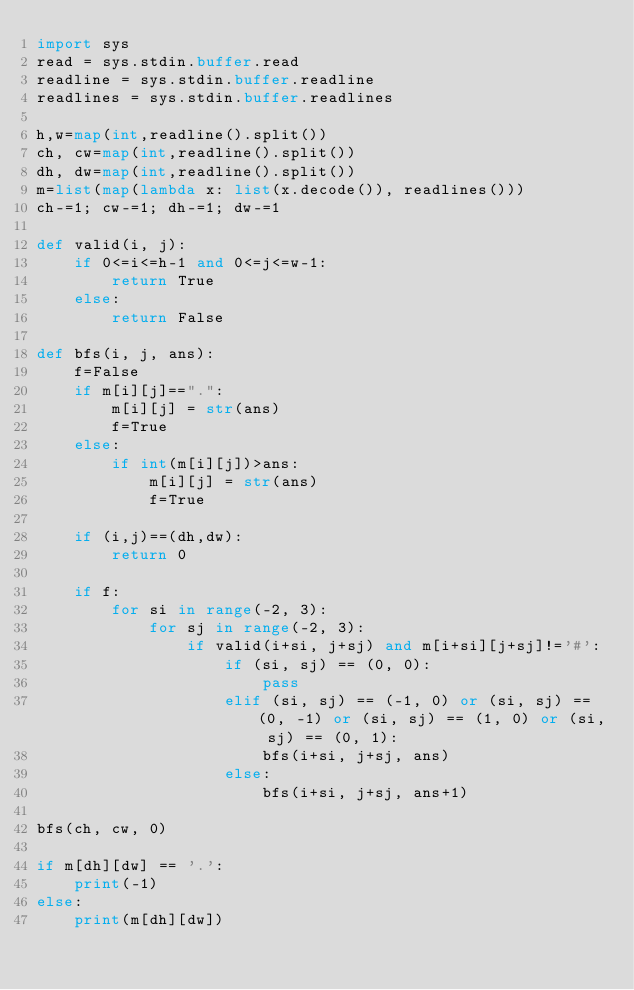Convert code to text. <code><loc_0><loc_0><loc_500><loc_500><_Python_>import sys
read = sys.stdin.buffer.read
readline = sys.stdin.buffer.readline
readlines = sys.stdin.buffer.readlines

h,w=map(int,readline().split())
ch, cw=map(int,readline().split())
dh, dw=map(int,readline().split())
m=list(map(lambda x: list(x.decode()), readlines()))
ch-=1; cw-=1; dh-=1; dw-=1

def valid(i, j):
    if 0<=i<=h-1 and 0<=j<=w-1:
        return True
    else:
        return False

def bfs(i, j, ans):
    f=False
    if m[i][j]==".":
        m[i][j] = str(ans)
        f=True
    else:
        if int(m[i][j])>ans:
            m[i][j] = str(ans)
            f=True
            
    if (i,j)==(dh,dw):
        return 0
    
    if f:
        for si in range(-2, 3):
            for sj in range(-2, 3):
                if valid(i+si, j+sj) and m[i+si][j+sj]!='#':
                    if (si, sj) == (0, 0):
                        pass
                    elif (si, sj) == (-1, 0) or (si, sj) == (0, -1) or (si, sj) == (1, 0) or (si, sj) == (0, 1):
                        bfs(i+si, j+sj, ans)
                    else:
                        bfs(i+si, j+sj, ans+1)
    
bfs(ch, cw, 0)

if m[dh][dw] == '.':
    print(-1)
else:
    print(m[dh][dw])</code> 